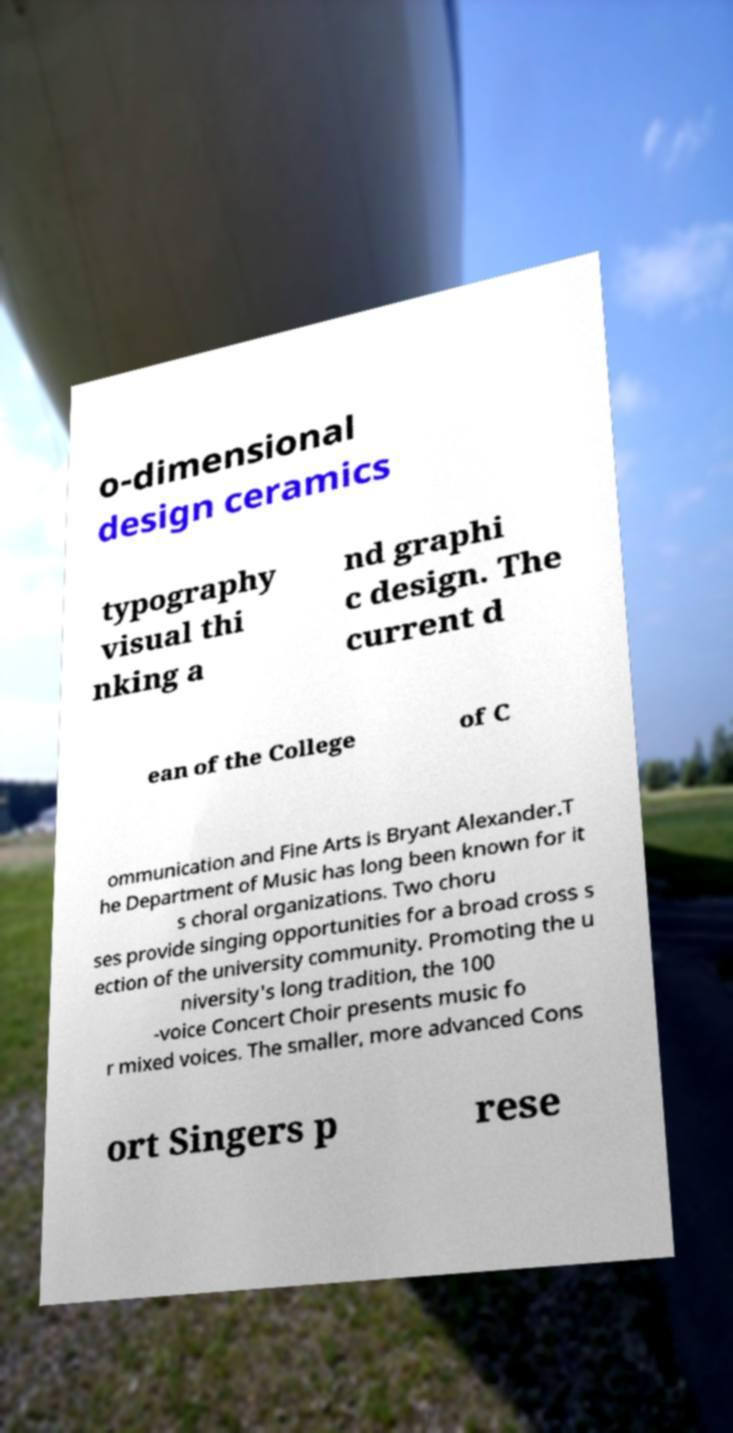There's text embedded in this image that I need extracted. Can you transcribe it verbatim? o-dimensional design ceramics typography visual thi nking a nd graphi c design. The current d ean of the College of C ommunication and Fine Arts is Bryant Alexander.T he Department of Music has long been known for it s choral organizations. Two choru ses provide singing opportunities for a broad cross s ection of the university community. Promoting the u niversity's long tradition, the 100 -voice Concert Choir presents music fo r mixed voices. The smaller, more advanced Cons ort Singers p rese 